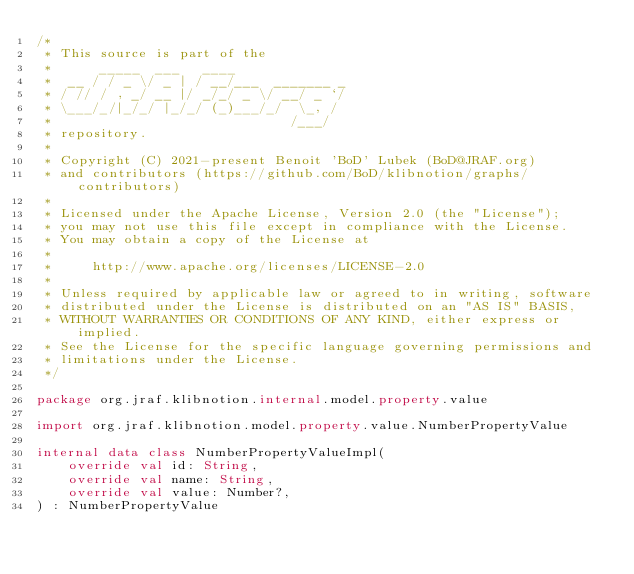<code> <loc_0><loc_0><loc_500><loc_500><_Kotlin_>/*
 * This source is part of the
 *      _____  ___   ____
 *  __ / / _ \/ _ | / __/___  _______ _
 * / // / , _/ __ |/ _/_/ _ \/ __/ _ `/
 * \___/_/|_/_/ |_/_/ (_)___/_/  \_, /
 *                              /___/
 * repository.
 *
 * Copyright (C) 2021-present Benoit 'BoD' Lubek (BoD@JRAF.org)
 * and contributors (https://github.com/BoD/klibnotion/graphs/contributors)
 *
 * Licensed under the Apache License, Version 2.0 (the "License");
 * you may not use this file except in compliance with the License.
 * You may obtain a copy of the License at
 *
 *     http://www.apache.org/licenses/LICENSE-2.0
 *
 * Unless required by applicable law or agreed to in writing, software
 * distributed under the License is distributed on an "AS IS" BASIS,
 * WITHOUT WARRANTIES OR CONDITIONS OF ANY KIND, either express or implied.
 * See the License for the specific language governing permissions and
 * limitations under the License.
 */

package org.jraf.klibnotion.internal.model.property.value

import org.jraf.klibnotion.model.property.value.NumberPropertyValue

internal data class NumberPropertyValueImpl(
    override val id: String,
    override val name: String,
    override val value: Number?,
) : NumberPropertyValue
</code> 